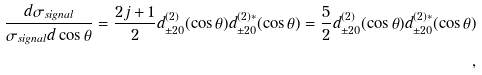Convert formula to latex. <formula><loc_0><loc_0><loc_500><loc_500>\frac { d \sigma _ { s i g n a l } } { \sigma _ { s i g n a l } d \cos \theta } = \frac { 2 j + 1 } { 2 } d ^ { ( 2 ) } _ { \pm 2 0 } ( \cos \theta ) d ^ { ( 2 ) * } _ { \pm 2 0 } ( \cos \theta ) = \frac { 5 } { 2 } d ^ { ( 2 ) } _ { \pm 2 0 } ( \cos \theta ) d ^ { ( 2 ) * } _ { \pm 2 0 } ( \cos \theta ) \\ ,</formula> 